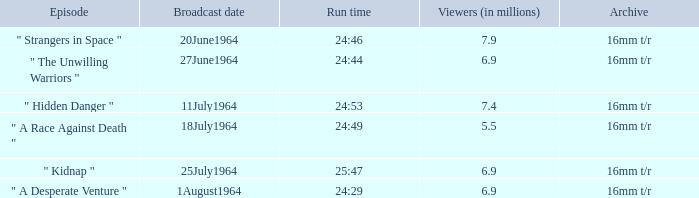How many individuals were in the audience on august 1, 1964? 6.9. 